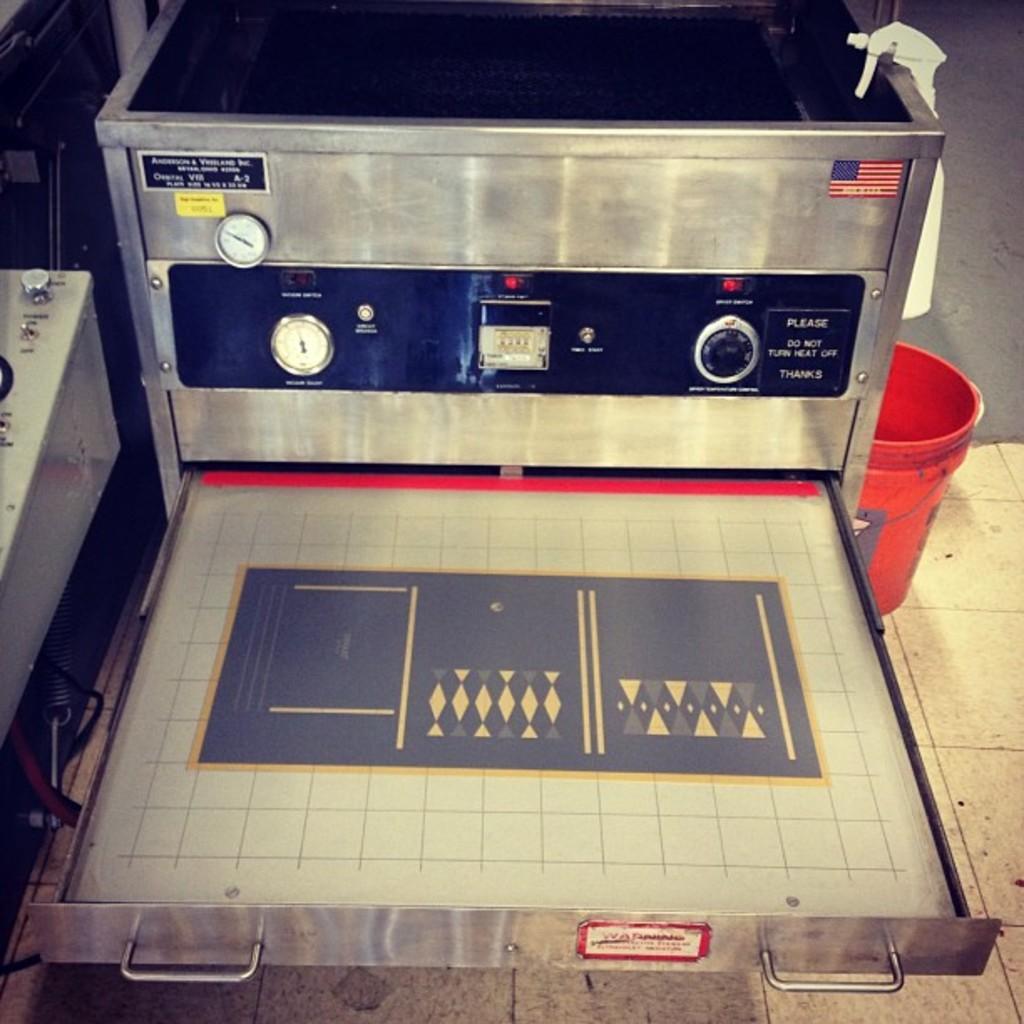In one or two sentences, can you explain what this image depicts? In this picture we can observe a machine which is in silver color. We can observe two meters which were in white color on this machine. On the right side we can observe a red color bucket. In the background there is a floor. 